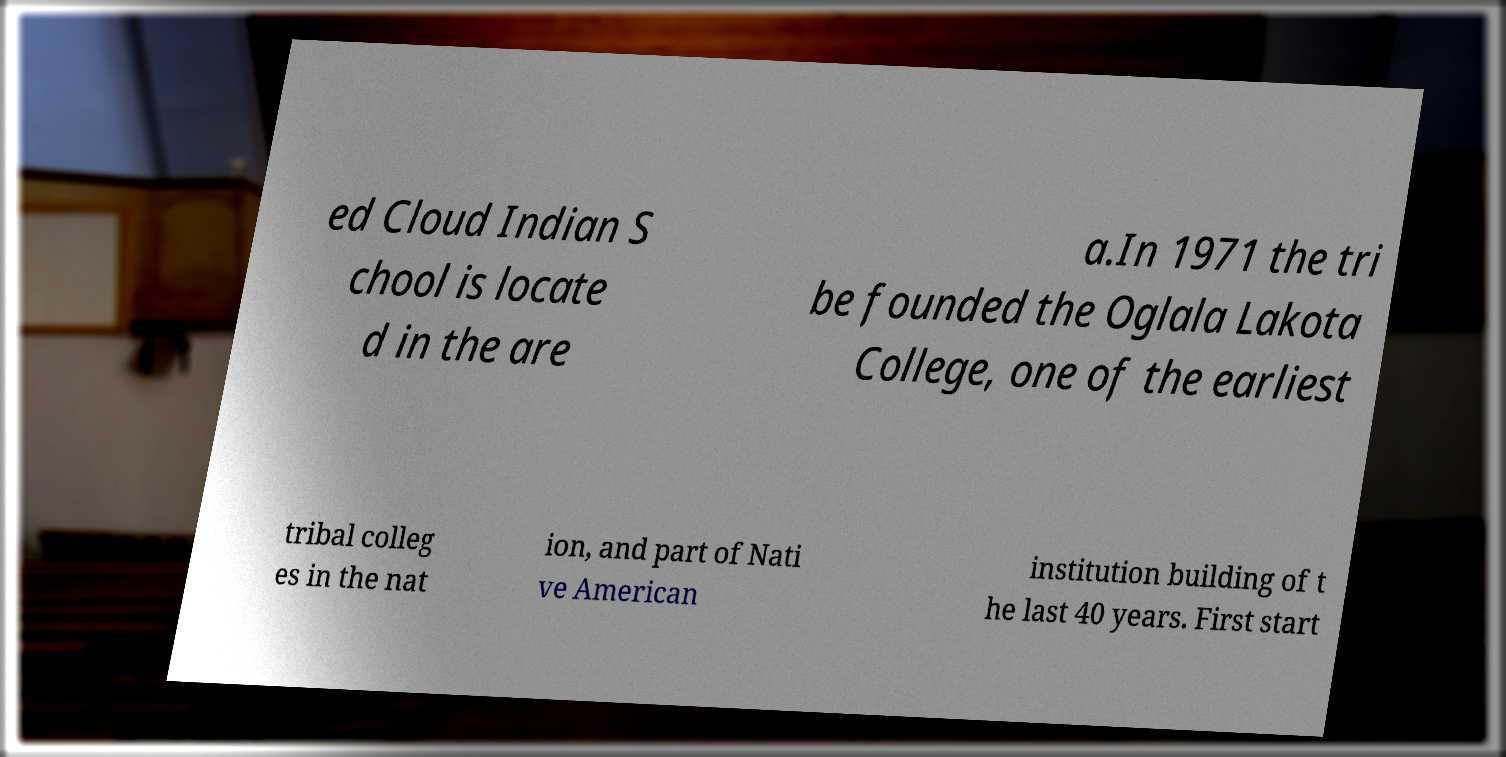For documentation purposes, I need the text within this image transcribed. Could you provide that? ed Cloud Indian S chool is locate d in the are a.In 1971 the tri be founded the Oglala Lakota College, one of the earliest tribal colleg es in the nat ion, and part of Nati ve American institution building of t he last 40 years. First start 